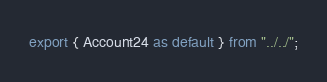<code> <loc_0><loc_0><loc_500><loc_500><_TypeScript_>export { Account24 as default } from "../../";
</code> 